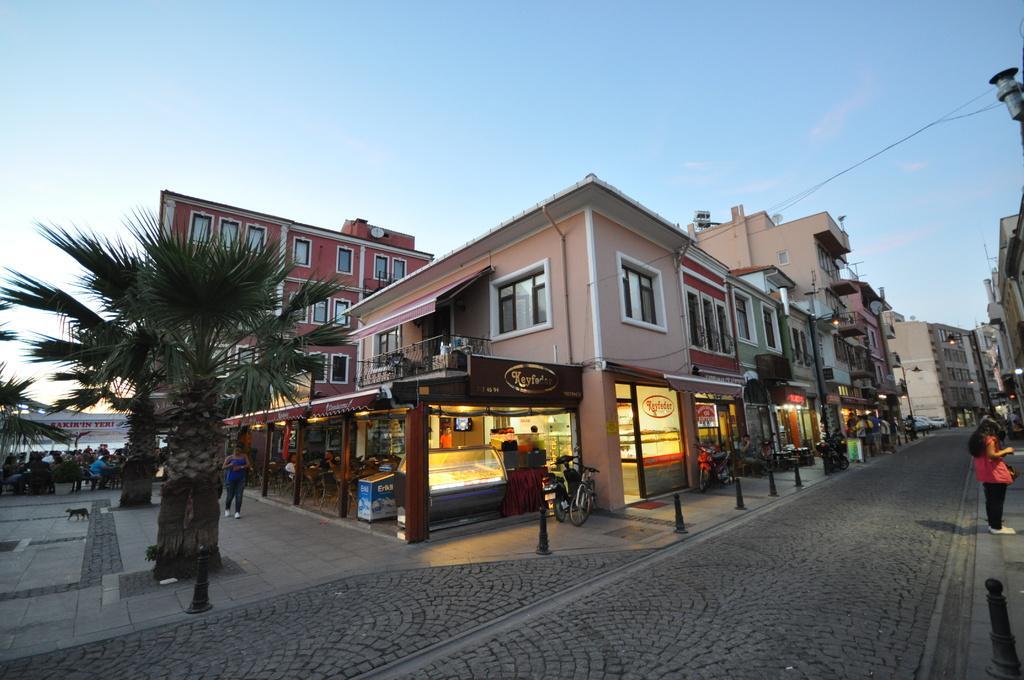Could you give a brief overview of what you see in this image? In this image I can see the road, a woman standing, few poles on the sidewalk, few bicycles, few trees, few persons sitting on chairs and few buildings. In the background I can see the sky. 